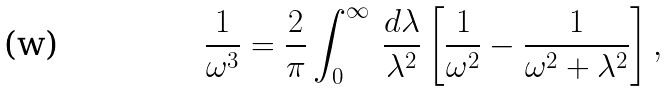Convert formula to latex. <formula><loc_0><loc_0><loc_500><loc_500>\frac { 1 } { \omega ^ { 3 } } = \frac { 2 } { \pi } \int _ { 0 } ^ { \infty } \, \frac { d \lambda } { \lambda ^ { 2 } } \left [ \frac { 1 } { \omega ^ { 2 } } - \frac { 1 } { \omega ^ { 2 } + \lambda ^ { 2 } } \right ] ,</formula> 